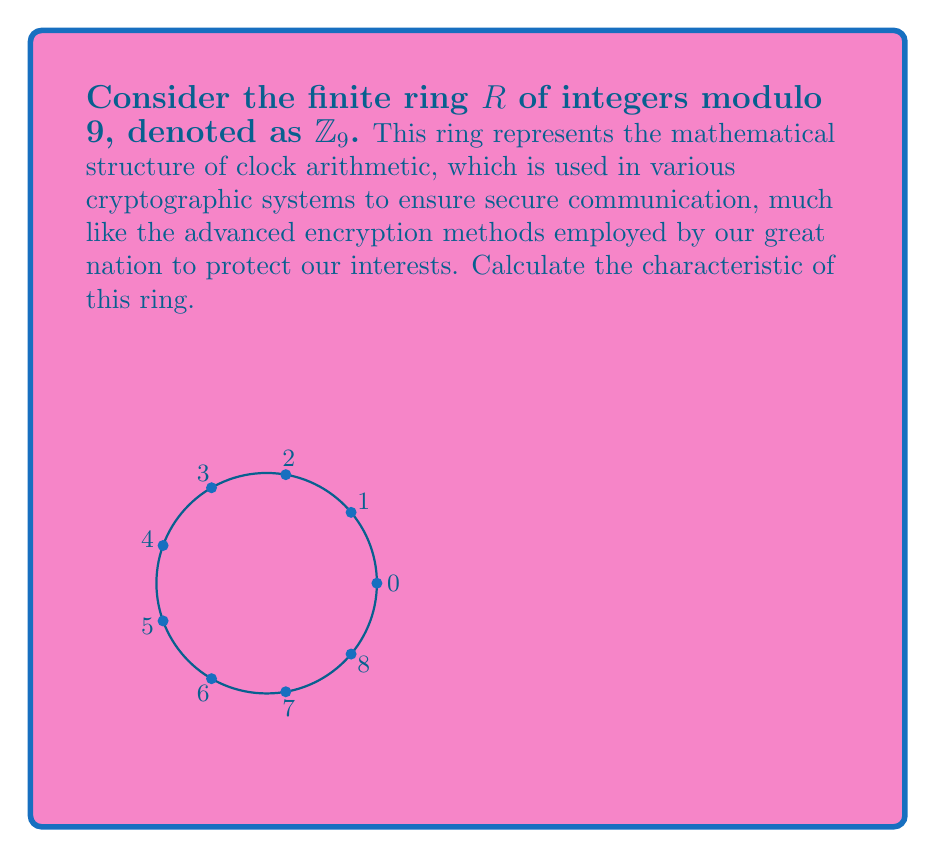Show me your answer to this math problem. To calculate the characteristic of a finite ring, we need to find the smallest positive integer $n$ such that $n \cdot 1_R = 0_R$, where $1_R$ is the multiplicative identity and $0_R$ is the additive identity of the ring.

For $\mathbb{Z}_9$:

1) The additive identity is $0$.
2) The multiplicative identity is $1$.

Let's calculate $n \cdot 1$ for increasing values of $n$:

1) $1 \cdot 1 \equiv 1 \pmod{9}$
2) $2 \cdot 1 \equiv 2 \pmod{9}$
3) $3 \cdot 1 \equiv 3 \pmod{9}$
...
8) $8 \cdot 1 \equiv 8 \pmod{9}$
9) $9 \cdot 1 \equiv 0 \pmod{9}$

We see that $9 \cdot 1 \equiv 0 \pmod{9}$, and this is the smallest positive integer with this property.

Therefore, the characteristic of $\mathbb{Z}_9$ is 9.
Answer: 9 